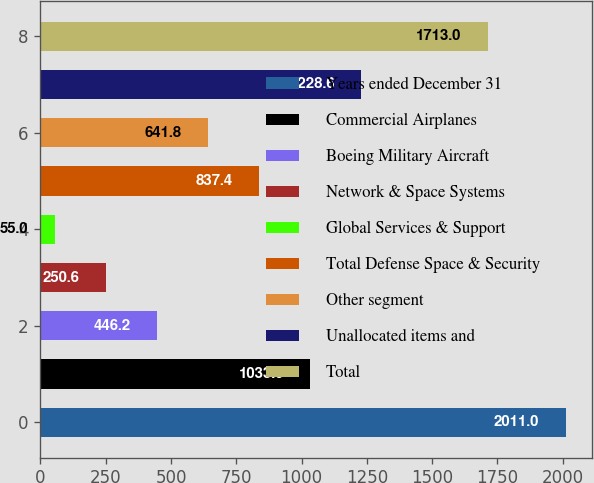Convert chart to OTSL. <chart><loc_0><loc_0><loc_500><loc_500><bar_chart><fcel>Years ended December 31<fcel>Commercial Airplanes<fcel>Boeing Military Aircraft<fcel>Network & Space Systems<fcel>Global Services & Support<fcel>Total Defense Space & Security<fcel>Other segment<fcel>Unallocated items and<fcel>Total<nl><fcel>2011<fcel>1033<fcel>446.2<fcel>250.6<fcel>55<fcel>837.4<fcel>641.8<fcel>1228.6<fcel>1713<nl></chart> 